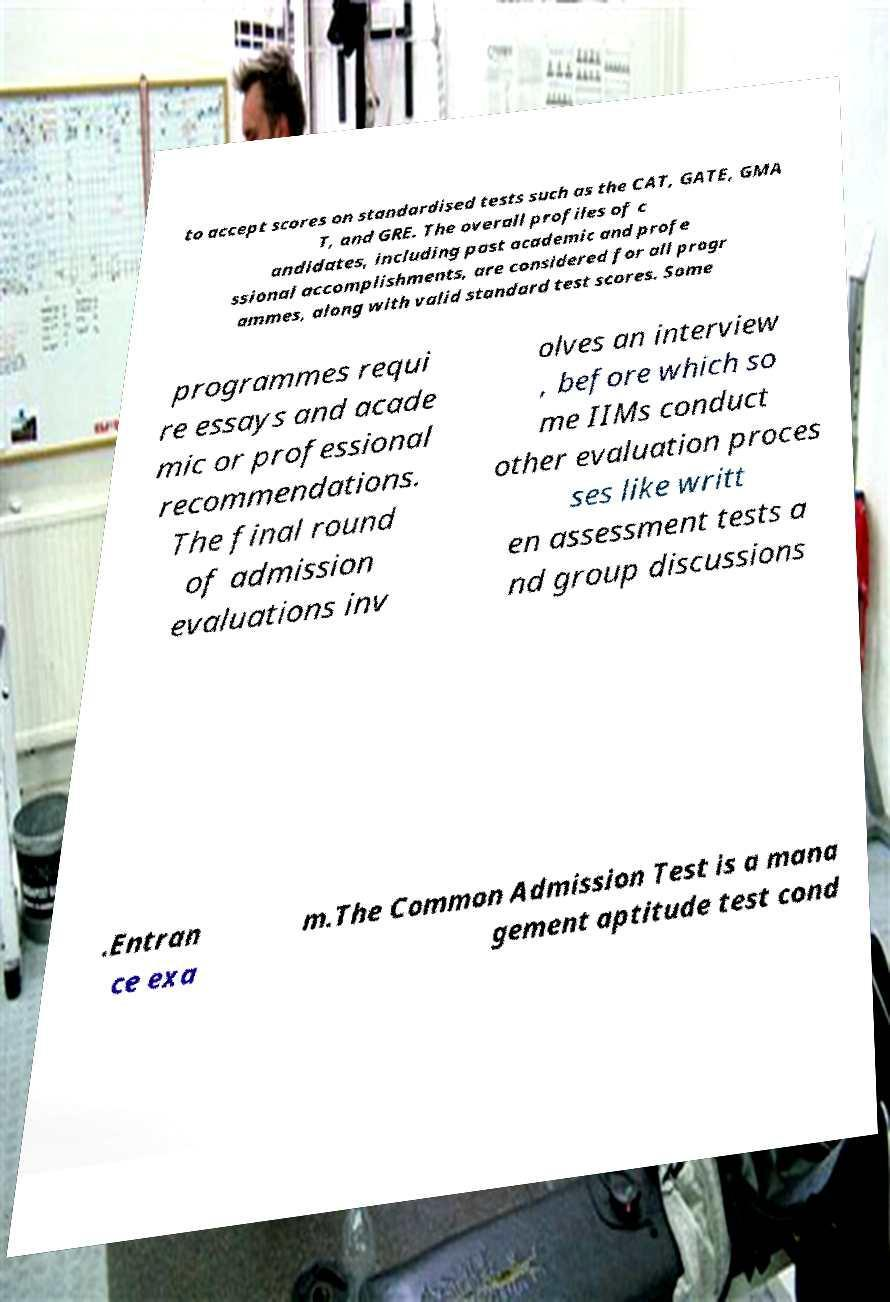What messages or text are displayed in this image? I need them in a readable, typed format. to accept scores on standardised tests such as the CAT, GATE, GMA T, and GRE. The overall profiles of c andidates, including past academic and profe ssional accomplishments, are considered for all progr ammes, along with valid standard test scores. Some programmes requi re essays and acade mic or professional recommendations. The final round of admission evaluations inv olves an interview , before which so me IIMs conduct other evaluation proces ses like writt en assessment tests a nd group discussions .Entran ce exa m.The Common Admission Test is a mana gement aptitude test cond 